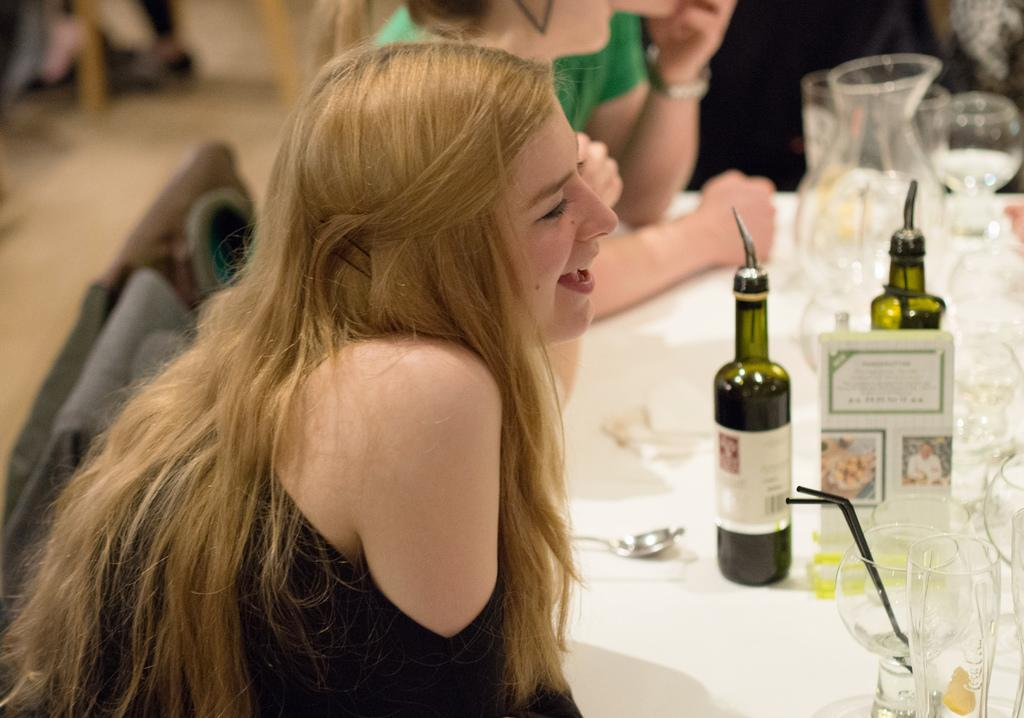What is the person in the image doing? The person is sitting on a chair in the image. What object is present in the image that the person might be using? There is a table in the image that the person might be using. What items can be seen on the table in the image? There are bottles on the table in the image. What type of cheese is being served on the table in the image? There is no cheese present in the image; only bottles can be seen on the table. 